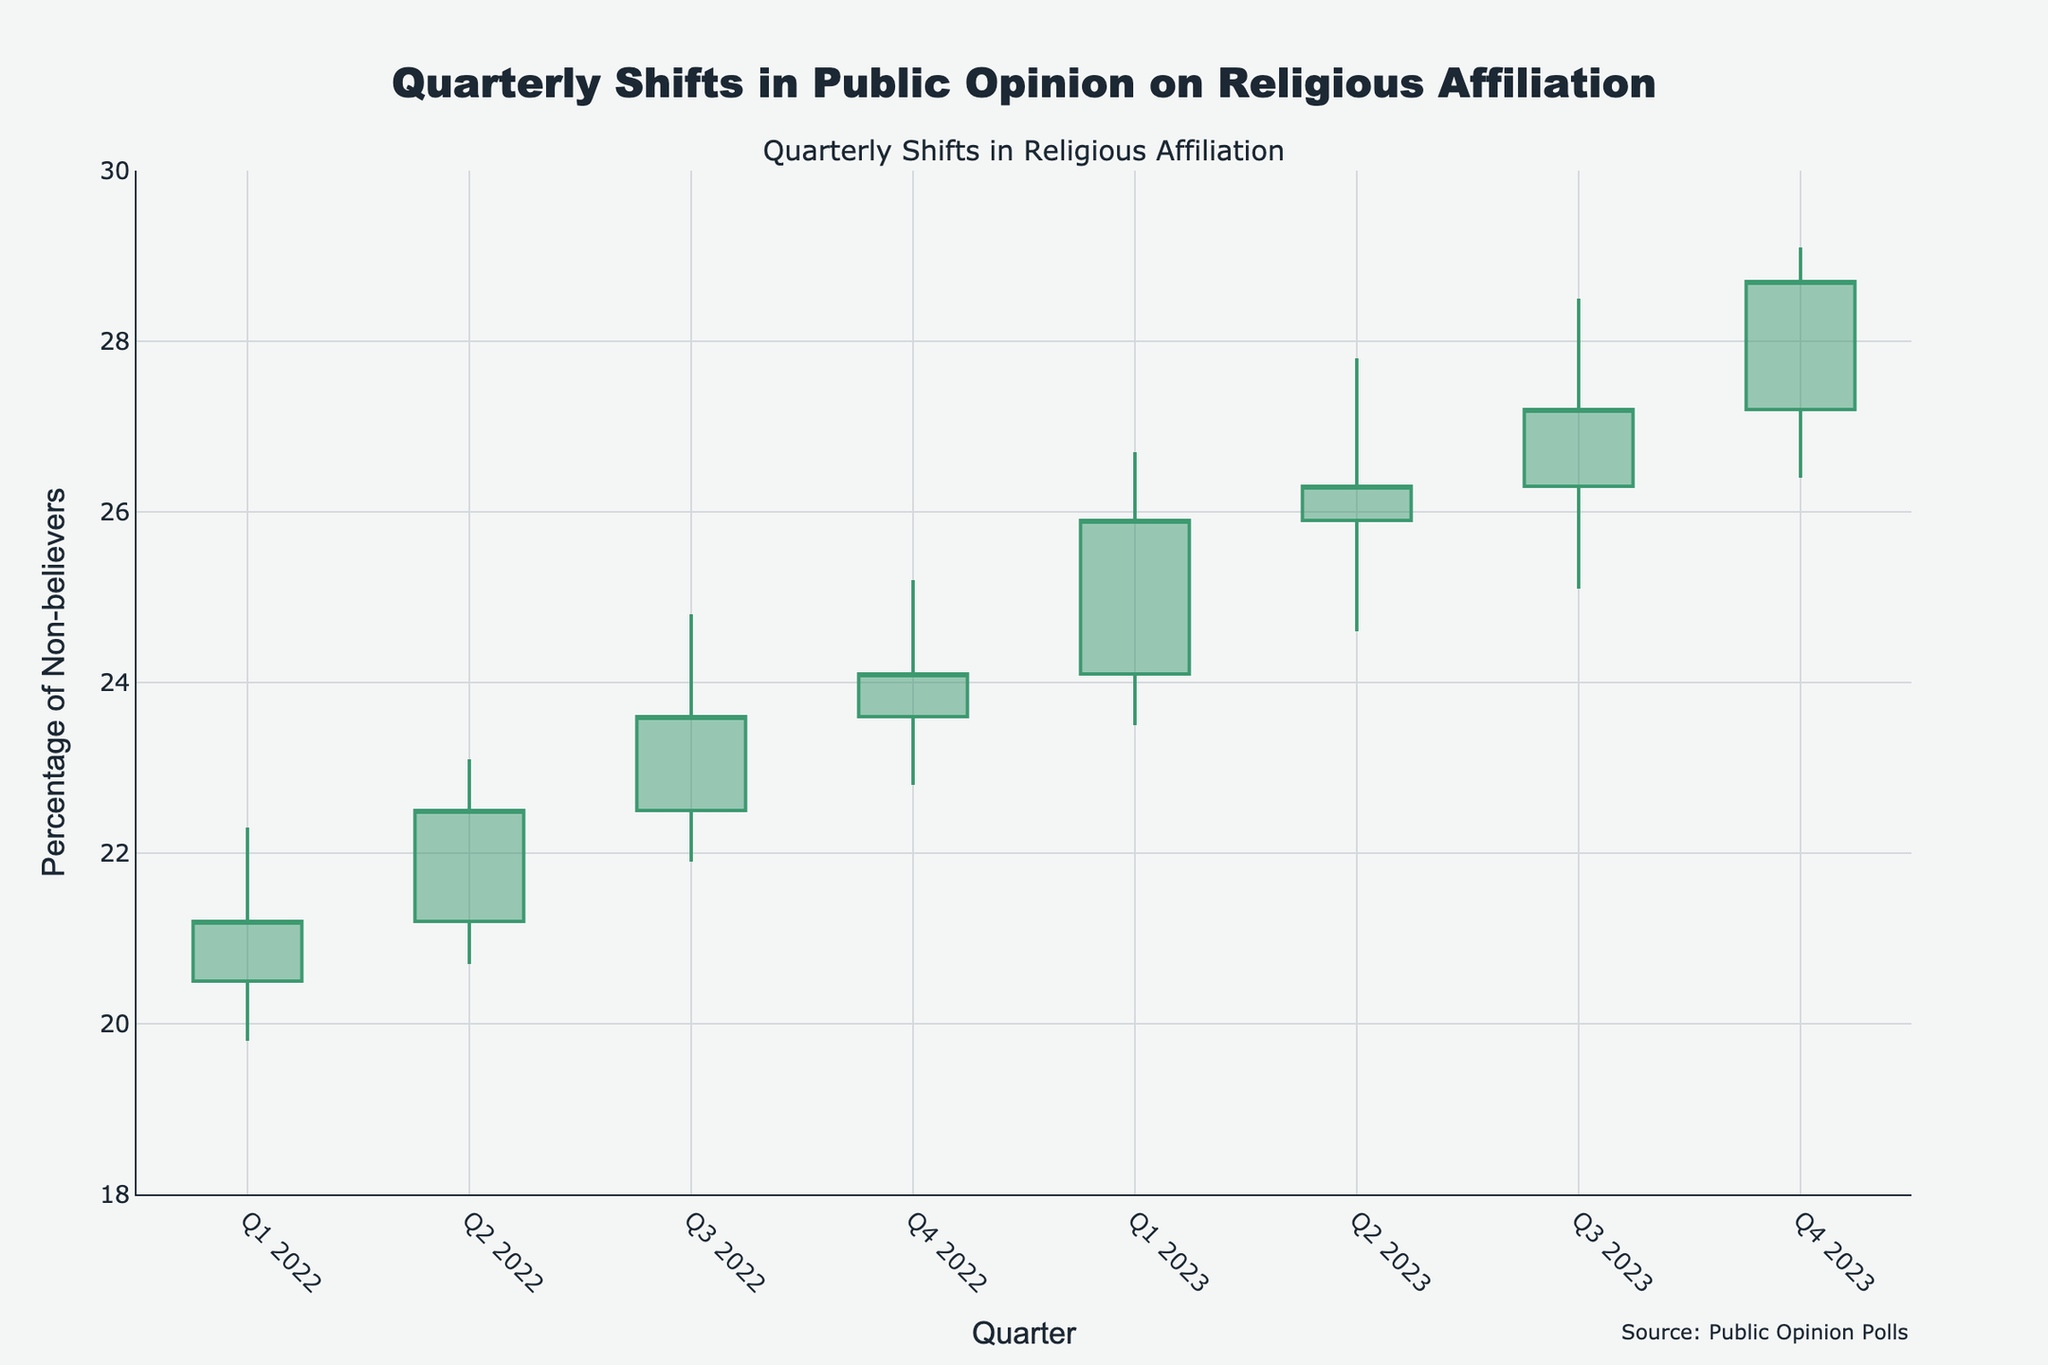what is the title of the chart? The title is displayed at the top of the chart. It reads "Quarterly Shifts in Public Opinion on Religious Affiliation".
Answer: Quarterly Shifts in Public Opinion on Religious Affiliation What does the y-axis represent? The y-axis label indicates it represents the "Percentage of Non-believers".
Answer: Percentage of Non-believers How many quarters are displayed in the chart? By reading the x-axis, you can count that there are eight quarters displayed from "Q1 2022" to "Q4 2023".
Answer: Eight What are the colors of the increasing and decreasing lines? The colors of the lines can be identified visually in the chart, with increasing lines in green and decreasing lines in red.
Answer: Green and Red What is the closing percentage of non-believers for Q2 2023? By looking at the closing value for the Q2 2023 candlestick, it is marked as 26.3%.
Answer: 26.3% Between Q3 2022 and Q4 2022, did the percentage of non-believers increase or decrease? By comparing the closing values, Q3 2022 closed at 23.6%, and Q4 2022 closed at 24.1%. The percentage increased.
Answer: Increase What is the average closing value for the year 2022? The closing values for 2022 are 21.2%, 22.5%, 23.6%, and 24.1%. The average is calculated as (21.2 + 22.5 + 23.6 + 24.1) / 4 = 22.85%.
Answer: 22.85% In which quarter was the highest value ever recorded, and what was it? By examining the high points for each quarter, the highest recorded value is 29.1% in Q4 2023.
Answer: Q4 2023, 29.1% What was the trend in the percentage of non-believers from Q1 2023 to Q2 2023, and what does this indicate? The percentage increased from a closing value of 25.9% to 26.3%. This indicates an upward trend in the percentage of non-believers over those quarters.
Answer: Upward trend Comparing Q1 2022 to Q4 2023, by how many percentage points did the closing value change? The closing value in Q1 2022 was 21.2%, and in Q4 2023, it was 28.7%. The change is calculated as 28.7% - 21.2% = 7.5%.
Answer: 7.5% 